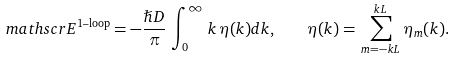Convert formula to latex. <formula><loc_0><loc_0><loc_500><loc_500>\ m a t h s c r { E } ^ { \text {1--loop} } = - \frac { \hslash D } { \pi } \, \int _ { 0 } ^ { \infty } \, k \, \eta ( k ) d k , \quad \eta ( k ) = \, \sum _ { m = - k L } ^ { k L } \eta _ { m } ( k ) . \,</formula> 